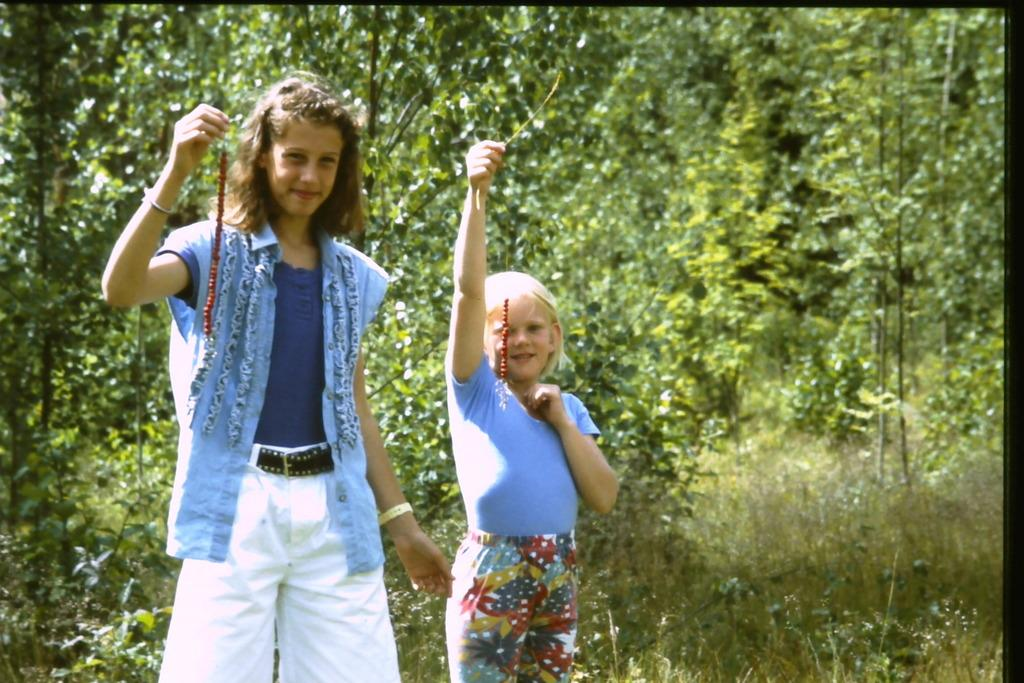How many people are in the image? There are two girls in the center of the image. What can be seen in the background of the image? There are trees in the background of the image. What hobbies do the girls share in the image? The provided facts do not mention any hobbies of the girls, so we cannot determine their shared hobbies from the image. 